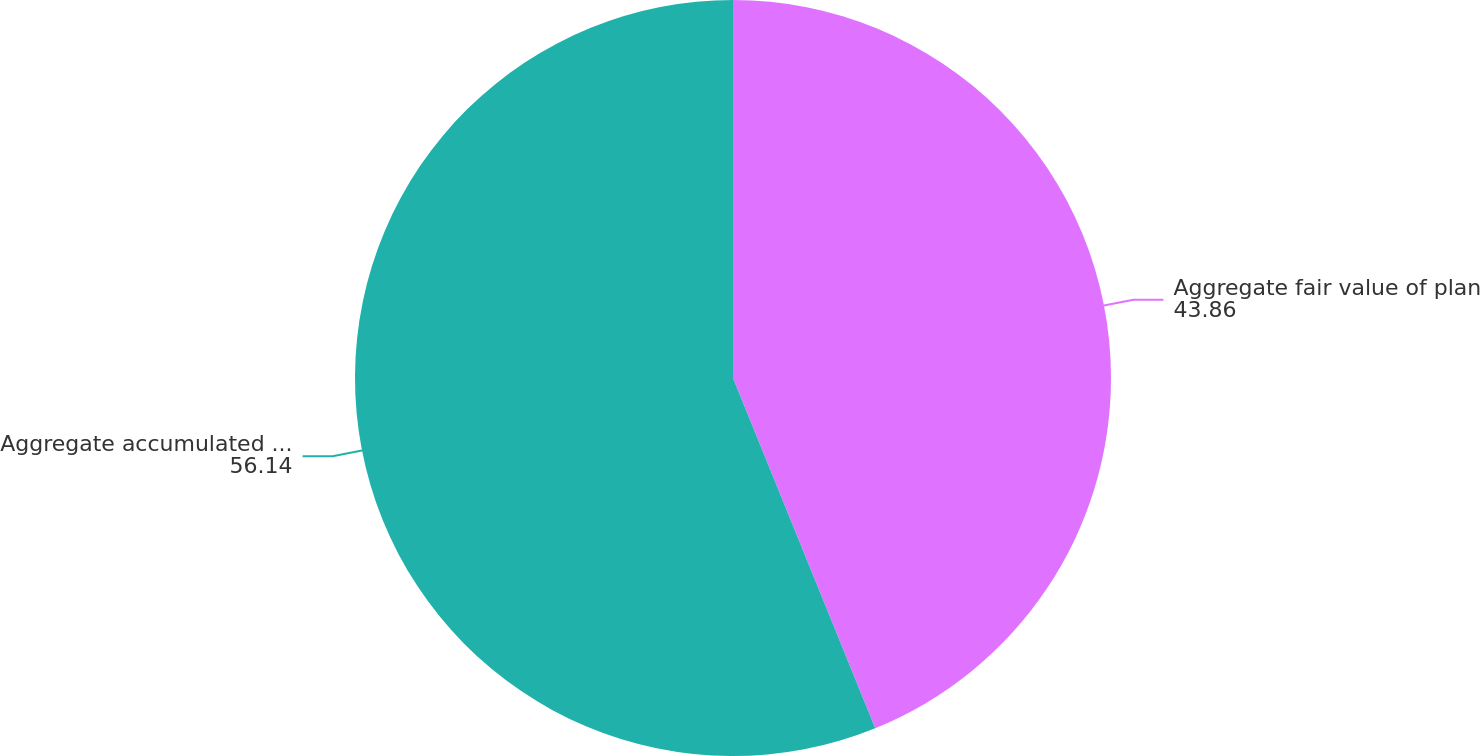<chart> <loc_0><loc_0><loc_500><loc_500><pie_chart><fcel>Aggregate fair value of plan<fcel>Aggregate accumulated benefit<nl><fcel>43.86%<fcel>56.14%<nl></chart> 